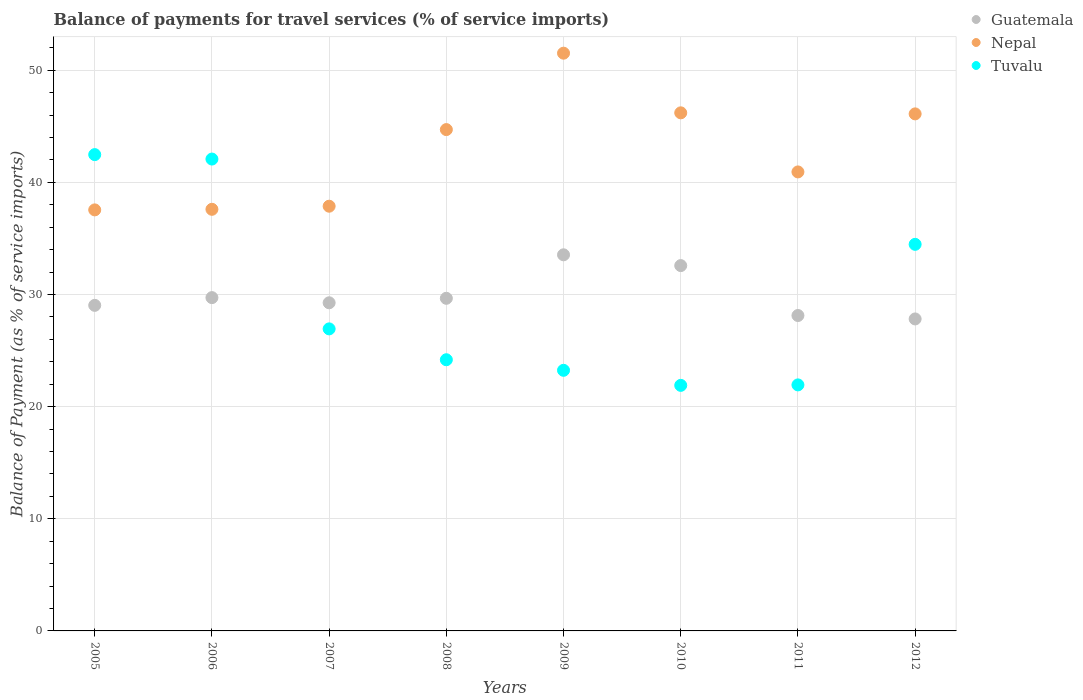How many different coloured dotlines are there?
Make the answer very short. 3. What is the balance of payments for travel services in Guatemala in 2005?
Offer a terse response. 29.03. Across all years, what is the maximum balance of payments for travel services in Tuvalu?
Offer a very short reply. 42.47. Across all years, what is the minimum balance of payments for travel services in Tuvalu?
Provide a short and direct response. 21.89. In which year was the balance of payments for travel services in Tuvalu maximum?
Provide a succinct answer. 2005. What is the total balance of payments for travel services in Tuvalu in the graph?
Ensure brevity in your answer.  237.19. What is the difference between the balance of payments for travel services in Guatemala in 2009 and that in 2010?
Provide a short and direct response. 0.96. What is the difference between the balance of payments for travel services in Tuvalu in 2007 and the balance of payments for travel services in Nepal in 2009?
Your response must be concise. -24.58. What is the average balance of payments for travel services in Nepal per year?
Provide a succinct answer. 42.8. In the year 2011, what is the difference between the balance of payments for travel services in Guatemala and balance of payments for travel services in Nepal?
Offer a terse response. -12.8. In how many years, is the balance of payments for travel services in Nepal greater than 18 %?
Your answer should be very brief. 8. What is the ratio of the balance of payments for travel services in Guatemala in 2005 to that in 2007?
Provide a short and direct response. 0.99. What is the difference between the highest and the second highest balance of payments for travel services in Guatemala?
Provide a succinct answer. 0.96. What is the difference between the highest and the lowest balance of payments for travel services in Guatemala?
Offer a terse response. 5.72. Is the balance of payments for travel services in Nepal strictly greater than the balance of payments for travel services in Guatemala over the years?
Give a very brief answer. Yes. Is the balance of payments for travel services in Guatemala strictly less than the balance of payments for travel services in Nepal over the years?
Your response must be concise. Yes. How many dotlines are there?
Your answer should be compact. 3. How many years are there in the graph?
Offer a terse response. 8. What is the difference between two consecutive major ticks on the Y-axis?
Provide a short and direct response. 10. Are the values on the major ticks of Y-axis written in scientific E-notation?
Provide a succinct answer. No. Does the graph contain any zero values?
Give a very brief answer. No. What is the title of the graph?
Offer a terse response. Balance of payments for travel services (% of service imports). What is the label or title of the Y-axis?
Offer a very short reply. Balance of Payment (as % of service imports). What is the Balance of Payment (as % of service imports) of Guatemala in 2005?
Ensure brevity in your answer.  29.03. What is the Balance of Payment (as % of service imports) of Nepal in 2005?
Offer a very short reply. 37.54. What is the Balance of Payment (as % of service imports) of Tuvalu in 2005?
Provide a succinct answer. 42.47. What is the Balance of Payment (as % of service imports) in Guatemala in 2006?
Keep it short and to the point. 29.72. What is the Balance of Payment (as % of service imports) of Nepal in 2006?
Give a very brief answer. 37.59. What is the Balance of Payment (as % of service imports) of Tuvalu in 2006?
Provide a short and direct response. 42.07. What is the Balance of Payment (as % of service imports) of Guatemala in 2007?
Your answer should be very brief. 29.26. What is the Balance of Payment (as % of service imports) of Nepal in 2007?
Make the answer very short. 37.87. What is the Balance of Payment (as % of service imports) of Tuvalu in 2007?
Offer a very short reply. 26.93. What is the Balance of Payment (as % of service imports) of Guatemala in 2008?
Provide a short and direct response. 29.66. What is the Balance of Payment (as % of service imports) of Nepal in 2008?
Your response must be concise. 44.7. What is the Balance of Payment (as % of service imports) in Tuvalu in 2008?
Keep it short and to the point. 24.18. What is the Balance of Payment (as % of service imports) of Guatemala in 2009?
Your response must be concise. 33.54. What is the Balance of Payment (as % of service imports) in Nepal in 2009?
Offer a very short reply. 51.51. What is the Balance of Payment (as % of service imports) of Tuvalu in 2009?
Offer a very short reply. 23.24. What is the Balance of Payment (as % of service imports) of Guatemala in 2010?
Offer a very short reply. 32.57. What is the Balance of Payment (as % of service imports) in Nepal in 2010?
Make the answer very short. 46.19. What is the Balance of Payment (as % of service imports) in Tuvalu in 2010?
Make the answer very short. 21.89. What is the Balance of Payment (as % of service imports) of Guatemala in 2011?
Make the answer very short. 28.12. What is the Balance of Payment (as % of service imports) of Nepal in 2011?
Your response must be concise. 40.93. What is the Balance of Payment (as % of service imports) in Tuvalu in 2011?
Give a very brief answer. 21.94. What is the Balance of Payment (as % of service imports) in Guatemala in 2012?
Keep it short and to the point. 27.82. What is the Balance of Payment (as % of service imports) of Nepal in 2012?
Make the answer very short. 46.1. What is the Balance of Payment (as % of service imports) in Tuvalu in 2012?
Provide a succinct answer. 34.47. Across all years, what is the maximum Balance of Payment (as % of service imports) of Guatemala?
Provide a short and direct response. 33.54. Across all years, what is the maximum Balance of Payment (as % of service imports) of Nepal?
Offer a very short reply. 51.51. Across all years, what is the maximum Balance of Payment (as % of service imports) in Tuvalu?
Give a very brief answer. 42.47. Across all years, what is the minimum Balance of Payment (as % of service imports) of Guatemala?
Give a very brief answer. 27.82. Across all years, what is the minimum Balance of Payment (as % of service imports) of Nepal?
Ensure brevity in your answer.  37.54. Across all years, what is the minimum Balance of Payment (as % of service imports) of Tuvalu?
Offer a very short reply. 21.89. What is the total Balance of Payment (as % of service imports) of Guatemala in the graph?
Provide a short and direct response. 239.71. What is the total Balance of Payment (as % of service imports) in Nepal in the graph?
Your answer should be very brief. 342.43. What is the total Balance of Payment (as % of service imports) of Tuvalu in the graph?
Offer a terse response. 237.19. What is the difference between the Balance of Payment (as % of service imports) in Guatemala in 2005 and that in 2006?
Your response must be concise. -0.69. What is the difference between the Balance of Payment (as % of service imports) of Nepal in 2005 and that in 2006?
Give a very brief answer. -0.05. What is the difference between the Balance of Payment (as % of service imports) of Tuvalu in 2005 and that in 2006?
Your response must be concise. 0.4. What is the difference between the Balance of Payment (as % of service imports) in Guatemala in 2005 and that in 2007?
Ensure brevity in your answer.  -0.23. What is the difference between the Balance of Payment (as % of service imports) of Nepal in 2005 and that in 2007?
Provide a short and direct response. -0.33. What is the difference between the Balance of Payment (as % of service imports) of Tuvalu in 2005 and that in 2007?
Offer a terse response. 15.54. What is the difference between the Balance of Payment (as % of service imports) in Guatemala in 2005 and that in 2008?
Offer a very short reply. -0.63. What is the difference between the Balance of Payment (as % of service imports) of Nepal in 2005 and that in 2008?
Keep it short and to the point. -7.16. What is the difference between the Balance of Payment (as % of service imports) of Tuvalu in 2005 and that in 2008?
Your response must be concise. 18.29. What is the difference between the Balance of Payment (as % of service imports) of Guatemala in 2005 and that in 2009?
Ensure brevity in your answer.  -4.51. What is the difference between the Balance of Payment (as % of service imports) in Nepal in 2005 and that in 2009?
Your response must be concise. -13.97. What is the difference between the Balance of Payment (as % of service imports) in Tuvalu in 2005 and that in 2009?
Offer a terse response. 19.23. What is the difference between the Balance of Payment (as % of service imports) in Guatemala in 2005 and that in 2010?
Provide a short and direct response. -3.54. What is the difference between the Balance of Payment (as % of service imports) of Nepal in 2005 and that in 2010?
Keep it short and to the point. -8.65. What is the difference between the Balance of Payment (as % of service imports) in Tuvalu in 2005 and that in 2010?
Your response must be concise. 20.57. What is the difference between the Balance of Payment (as % of service imports) in Guatemala in 2005 and that in 2011?
Offer a terse response. 0.91. What is the difference between the Balance of Payment (as % of service imports) of Nepal in 2005 and that in 2011?
Offer a very short reply. -3.39. What is the difference between the Balance of Payment (as % of service imports) in Tuvalu in 2005 and that in 2011?
Ensure brevity in your answer.  20.53. What is the difference between the Balance of Payment (as % of service imports) in Guatemala in 2005 and that in 2012?
Your response must be concise. 1.21. What is the difference between the Balance of Payment (as % of service imports) of Nepal in 2005 and that in 2012?
Provide a succinct answer. -8.56. What is the difference between the Balance of Payment (as % of service imports) of Tuvalu in 2005 and that in 2012?
Ensure brevity in your answer.  8. What is the difference between the Balance of Payment (as % of service imports) of Guatemala in 2006 and that in 2007?
Give a very brief answer. 0.46. What is the difference between the Balance of Payment (as % of service imports) in Nepal in 2006 and that in 2007?
Offer a very short reply. -0.28. What is the difference between the Balance of Payment (as % of service imports) in Tuvalu in 2006 and that in 2007?
Your answer should be very brief. 15.14. What is the difference between the Balance of Payment (as % of service imports) in Guatemala in 2006 and that in 2008?
Your answer should be very brief. 0.06. What is the difference between the Balance of Payment (as % of service imports) of Nepal in 2006 and that in 2008?
Your response must be concise. -7.11. What is the difference between the Balance of Payment (as % of service imports) of Tuvalu in 2006 and that in 2008?
Your answer should be compact. 17.89. What is the difference between the Balance of Payment (as % of service imports) in Guatemala in 2006 and that in 2009?
Offer a terse response. -3.82. What is the difference between the Balance of Payment (as % of service imports) in Nepal in 2006 and that in 2009?
Offer a very short reply. -13.92. What is the difference between the Balance of Payment (as % of service imports) in Tuvalu in 2006 and that in 2009?
Give a very brief answer. 18.84. What is the difference between the Balance of Payment (as % of service imports) in Guatemala in 2006 and that in 2010?
Your response must be concise. -2.86. What is the difference between the Balance of Payment (as % of service imports) of Nepal in 2006 and that in 2010?
Give a very brief answer. -8.6. What is the difference between the Balance of Payment (as % of service imports) in Tuvalu in 2006 and that in 2010?
Your answer should be very brief. 20.18. What is the difference between the Balance of Payment (as % of service imports) in Guatemala in 2006 and that in 2011?
Your response must be concise. 1.59. What is the difference between the Balance of Payment (as % of service imports) in Nepal in 2006 and that in 2011?
Offer a very short reply. -3.33. What is the difference between the Balance of Payment (as % of service imports) of Tuvalu in 2006 and that in 2011?
Provide a succinct answer. 20.14. What is the difference between the Balance of Payment (as % of service imports) of Guatemala in 2006 and that in 2012?
Keep it short and to the point. 1.9. What is the difference between the Balance of Payment (as % of service imports) in Nepal in 2006 and that in 2012?
Your answer should be very brief. -8.51. What is the difference between the Balance of Payment (as % of service imports) in Tuvalu in 2006 and that in 2012?
Provide a short and direct response. 7.6. What is the difference between the Balance of Payment (as % of service imports) in Guatemala in 2007 and that in 2008?
Provide a succinct answer. -0.4. What is the difference between the Balance of Payment (as % of service imports) of Nepal in 2007 and that in 2008?
Make the answer very short. -6.83. What is the difference between the Balance of Payment (as % of service imports) of Tuvalu in 2007 and that in 2008?
Keep it short and to the point. 2.75. What is the difference between the Balance of Payment (as % of service imports) in Guatemala in 2007 and that in 2009?
Make the answer very short. -4.28. What is the difference between the Balance of Payment (as % of service imports) in Nepal in 2007 and that in 2009?
Make the answer very short. -13.64. What is the difference between the Balance of Payment (as % of service imports) in Tuvalu in 2007 and that in 2009?
Make the answer very short. 3.69. What is the difference between the Balance of Payment (as % of service imports) of Guatemala in 2007 and that in 2010?
Your answer should be compact. -3.32. What is the difference between the Balance of Payment (as % of service imports) of Nepal in 2007 and that in 2010?
Provide a short and direct response. -8.33. What is the difference between the Balance of Payment (as % of service imports) in Tuvalu in 2007 and that in 2010?
Keep it short and to the point. 5.04. What is the difference between the Balance of Payment (as % of service imports) in Guatemala in 2007 and that in 2011?
Provide a succinct answer. 1.13. What is the difference between the Balance of Payment (as % of service imports) in Nepal in 2007 and that in 2011?
Give a very brief answer. -3.06. What is the difference between the Balance of Payment (as % of service imports) of Tuvalu in 2007 and that in 2011?
Offer a terse response. 4.99. What is the difference between the Balance of Payment (as % of service imports) of Guatemala in 2007 and that in 2012?
Ensure brevity in your answer.  1.44. What is the difference between the Balance of Payment (as % of service imports) in Nepal in 2007 and that in 2012?
Your response must be concise. -8.23. What is the difference between the Balance of Payment (as % of service imports) in Tuvalu in 2007 and that in 2012?
Give a very brief answer. -7.54. What is the difference between the Balance of Payment (as % of service imports) of Guatemala in 2008 and that in 2009?
Give a very brief answer. -3.88. What is the difference between the Balance of Payment (as % of service imports) in Nepal in 2008 and that in 2009?
Your answer should be compact. -6.81. What is the difference between the Balance of Payment (as % of service imports) in Tuvalu in 2008 and that in 2009?
Give a very brief answer. 0.94. What is the difference between the Balance of Payment (as % of service imports) in Guatemala in 2008 and that in 2010?
Offer a very short reply. -2.92. What is the difference between the Balance of Payment (as % of service imports) in Nepal in 2008 and that in 2010?
Ensure brevity in your answer.  -1.49. What is the difference between the Balance of Payment (as % of service imports) of Tuvalu in 2008 and that in 2010?
Keep it short and to the point. 2.28. What is the difference between the Balance of Payment (as % of service imports) of Guatemala in 2008 and that in 2011?
Provide a succinct answer. 1.53. What is the difference between the Balance of Payment (as % of service imports) in Nepal in 2008 and that in 2011?
Offer a very short reply. 3.77. What is the difference between the Balance of Payment (as % of service imports) of Tuvalu in 2008 and that in 2011?
Offer a very short reply. 2.24. What is the difference between the Balance of Payment (as % of service imports) of Guatemala in 2008 and that in 2012?
Your response must be concise. 1.84. What is the difference between the Balance of Payment (as % of service imports) of Nepal in 2008 and that in 2012?
Your answer should be compact. -1.4. What is the difference between the Balance of Payment (as % of service imports) in Tuvalu in 2008 and that in 2012?
Offer a terse response. -10.29. What is the difference between the Balance of Payment (as % of service imports) in Guatemala in 2009 and that in 2010?
Make the answer very short. 0.96. What is the difference between the Balance of Payment (as % of service imports) in Nepal in 2009 and that in 2010?
Offer a very short reply. 5.32. What is the difference between the Balance of Payment (as % of service imports) in Tuvalu in 2009 and that in 2010?
Your answer should be very brief. 1.34. What is the difference between the Balance of Payment (as % of service imports) of Guatemala in 2009 and that in 2011?
Provide a succinct answer. 5.41. What is the difference between the Balance of Payment (as % of service imports) in Nepal in 2009 and that in 2011?
Provide a succinct answer. 10.59. What is the difference between the Balance of Payment (as % of service imports) in Tuvalu in 2009 and that in 2011?
Your response must be concise. 1.3. What is the difference between the Balance of Payment (as % of service imports) in Guatemala in 2009 and that in 2012?
Ensure brevity in your answer.  5.72. What is the difference between the Balance of Payment (as % of service imports) in Nepal in 2009 and that in 2012?
Make the answer very short. 5.41. What is the difference between the Balance of Payment (as % of service imports) in Tuvalu in 2009 and that in 2012?
Your response must be concise. -11.23. What is the difference between the Balance of Payment (as % of service imports) of Guatemala in 2010 and that in 2011?
Make the answer very short. 4.45. What is the difference between the Balance of Payment (as % of service imports) in Nepal in 2010 and that in 2011?
Offer a very short reply. 5.27. What is the difference between the Balance of Payment (as % of service imports) in Tuvalu in 2010 and that in 2011?
Give a very brief answer. -0.04. What is the difference between the Balance of Payment (as % of service imports) of Guatemala in 2010 and that in 2012?
Offer a terse response. 4.76. What is the difference between the Balance of Payment (as % of service imports) in Nepal in 2010 and that in 2012?
Give a very brief answer. 0.09. What is the difference between the Balance of Payment (as % of service imports) of Tuvalu in 2010 and that in 2012?
Keep it short and to the point. -12.57. What is the difference between the Balance of Payment (as % of service imports) of Guatemala in 2011 and that in 2012?
Your answer should be very brief. 0.31. What is the difference between the Balance of Payment (as % of service imports) in Nepal in 2011 and that in 2012?
Provide a succinct answer. -5.17. What is the difference between the Balance of Payment (as % of service imports) of Tuvalu in 2011 and that in 2012?
Your response must be concise. -12.53. What is the difference between the Balance of Payment (as % of service imports) of Guatemala in 2005 and the Balance of Payment (as % of service imports) of Nepal in 2006?
Make the answer very short. -8.56. What is the difference between the Balance of Payment (as % of service imports) of Guatemala in 2005 and the Balance of Payment (as % of service imports) of Tuvalu in 2006?
Make the answer very short. -13.04. What is the difference between the Balance of Payment (as % of service imports) of Nepal in 2005 and the Balance of Payment (as % of service imports) of Tuvalu in 2006?
Your answer should be very brief. -4.53. What is the difference between the Balance of Payment (as % of service imports) in Guatemala in 2005 and the Balance of Payment (as % of service imports) in Nepal in 2007?
Keep it short and to the point. -8.84. What is the difference between the Balance of Payment (as % of service imports) in Guatemala in 2005 and the Balance of Payment (as % of service imports) in Tuvalu in 2007?
Give a very brief answer. 2.1. What is the difference between the Balance of Payment (as % of service imports) of Nepal in 2005 and the Balance of Payment (as % of service imports) of Tuvalu in 2007?
Provide a short and direct response. 10.61. What is the difference between the Balance of Payment (as % of service imports) in Guatemala in 2005 and the Balance of Payment (as % of service imports) in Nepal in 2008?
Your answer should be compact. -15.67. What is the difference between the Balance of Payment (as % of service imports) of Guatemala in 2005 and the Balance of Payment (as % of service imports) of Tuvalu in 2008?
Your answer should be compact. 4.85. What is the difference between the Balance of Payment (as % of service imports) of Nepal in 2005 and the Balance of Payment (as % of service imports) of Tuvalu in 2008?
Ensure brevity in your answer.  13.36. What is the difference between the Balance of Payment (as % of service imports) in Guatemala in 2005 and the Balance of Payment (as % of service imports) in Nepal in 2009?
Your response must be concise. -22.48. What is the difference between the Balance of Payment (as % of service imports) in Guatemala in 2005 and the Balance of Payment (as % of service imports) in Tuvalu in 2009?
Provide a short and direct response. 5.79. What is the difference between the Balance of Payment (as % of service imports) of Nepal in 2005 and the Balance of Payment (as % of service imports) of Tuvalu in 2009?
Offer a terse response. 14.3. What is the difference between the Balance of Payment (as % of service imports) of Guatemala in 2005 and the Balance of Payment (as % of service imports) of Nepal in 2010?
Your response must be concise. -17.16. What is the difference between the Balance of Payment (as % of service imports) in Guatemala in 2005 and the Balance of Payment (as % of service imports) in Tuvalu in 2010?
Keep it short and to the point. 7.13. What is the difference between the Balance of Payment (as % of service imports) of Nepal in 2005 and the Balance of Payment (as % of service imports) of Tuvalu in 2010?
Your answer should be very brief. 15.65. What is the difference between the Balance of Payment (as % of service imports) in Guatemala in 2005 and the Balance of Payment (as % of service imports) in Nepal in 2011?
Offer a terse response. -11.9. What is the difference between the Balance of Payment (as % of service imports) of Guatemala in 2005 and the Balance of Payment (as % of service imports) of Tuvalu in 2011?
Offer a very short reply. 7.09. What is the difference between the Balance of Payment (as % of service imports) of Nepal in 2005 and the Balance of Payment (as % of service imports) of Tuvalu in 2011?
Offer a very short reply. 15.6. What is the difference between the Balance of Payment (as % of service imports) in Guatemala in 2005 and the Balance of Payment (as % of service imports) in Nepal in 2012?
Provide a succinct answer. -17.07. What is the difference between the Balance of Payment (as % of service imports) of Guatemala in 2005 and the Balance of Payment (as % of service imports) of Tuvalu in 2012?
Provide a succinct answer. -5.44. What is the difference between the Balance of Payment (as % of service imports) of Nepal in 2005 and the Balance of Payment (as % of service imports) of Tuvalu in 2012?
Offer a terse response. 3.07. What is the difference between the Balance of Payment (as % of service imports) in Guatemala in 2006 and the Balance of Payment (as % of service imports) in Nepal in 2007?
Your answer should be compact. -8.15. What is the difference between the Balance of Payment (as % of service imports) of Guatemala in 2006 and the Balance of Payment (as % of service imports) of Tuvalu in 2007?
Ensure brevity in your answer.  2.79. What is the difference between the Balance of Payment (as % of service imports) in Nepal in 2006 and the Balance of Payment (as % of service imports) in Tuvalu in 2007?
Ensure brevity in your answer.  10.66. What is the difference between the Balance of Payment (as % of service imports) in Guatemala in 2006 and the Balance of Payment (as % of service imports) in Nepal in 2008?
Keep it short and to the point. -14.98. What is the difference between the Balance of Payment (as % of service imports) of Guatemala in 2006 and the Balance of Payment (as % of service imports) of Tuvalu in 2008?
Offer a very short reply. 5.54. What is the difference between the Balance of Payment (as % of service imports) in Nepal in 2006 and the Balance of Payment (as % of service imports) in Tuvalu in 2008?
Offer a very short reply. 13.41. What is the difference between the Balance of Payment (as % of service imports) of Guatemala in 2006 and the Balance of Payment (as % of service imports) of Nepal in 2009?
Keep it short and to the point. -21.79. What is the difference between the Balance of Payment (as % of service imports) of Guatemala in 2006 and the Balance of Payment (as % of service imports) of Tuvalu in 2009?
Your answer should be compact. 6.48. What is the difference between the Balance of Payment (as % of service imports) in Nepal in 2006 and the Balance of Payment (as % of service imports) in Tuvalu in 2009?
Keep it short and to the point. 14.36. What is the difference between the Balance of Payment (as % of service imports) in Guatemala in 2006 and the Balance of Payment (as % of service imports) in Nepal in 2010?
Provide a short and direct response. -16.48. What is the difference between the Balance of Payment (as % of service imports) in Guatemala in 2006 and the Balance of Payment (as % of service imports) in Tuvalu in 2010?
Ensure brevity in your answer.  7.82. What is the difference between the Balance of Payment (as % of service imports) in Nepal in 2006 and the Balance of Payment (as % of service imports) in Tuvalu in 2010?
Your answer should be very brief. 15.7. What is the difference between the Balance of Payment (as % of service imports) in Guatemala in 2006 and the Balance of Payment (as % of service imports) in Nepal in 2011?
Ensure brevity in your answer.  -11.21. What is the difference between the Balance of Payment (as % of service imports) of Guatemala in 2006 and the Balance of Payment (as % of service imports) of Tuvalu in 2011?
Keep it short and to the point. 7.78. What is the difference between the Balance of Payment (as % of service imports) of Nepal in 2006 and the Balance of Payment (as % of service imports) of Tuvalu in 2011?
Give a very brief answer. 15.66. What is the difference between the Balance of Payment (as % of service imports) of Guatemala in 2006 and the Balance of Payment (as % of service imports) of Nepal in 2012?
Ensure brevity in your answer.  -16.38. What is the difference between the Balance of Payment (as % of service imports) in Guatemala in 2006 and the Balance of Payment (as % of service imports) in Tuvalu in 2012?
Keep it short and to the point. -4.75. What is the difference between the Balance of Payment (as % of service imports) of Nepal in 2006 and the Balance of Payment (as % of service imports) of Tuvalu in 2012?
Offer a very short reply. 3.12. What is the difference between the Balance of Payment (as % of service imports) of Guatemala in 2007 and the Balance of Payment (as % of service imports) of Nepal in 2008?
Your answer should be compact. -15.44. What is the difference between the Balance of Payment (as % of service imports) of Guatemala in 2007 and the Balance of Payment (as % of service imports) of Tuvalu in 2008?
Ensure brevity in your answer.  5.08. What is the difference between the Balance of Payment (as % of service imports) of Nepal in 2007 and the Balance of Payment (as % of service imports) of Tuvalu in 2008?
Ensure brevity in your answer.  13.69. What is the difference between the Balance of Payment (as % of service imports) of Guatemala in 2007 and the Balance of Payment (as % of service imports) of Nepal in 2009?
Make the answer very short. -22.25. What is the difference between the Balance of Payment (as % of service imports) of Guatemala in 2007 and the Balance of Payment (as % of service imports) of Tuvalu in 2009?
Offer a terse response. 6.02. What is the difference between the Balance of Payment (as % of service imports) in Nepal in 2007 and the Balance of Payment (as % of service imports) in Tuvalu in 2009?
Make the answer very short. 14.63. What is the difference between the Balance of Payment (as % of service imports) in Guatemala in 2007 and the Balance of Payment (as % of service imports) in Nepal in 2010?
Provide a short and direct response. -16.94. What is the difference between the Balance of Payment (as % of service imports) in Guatemala in 2007 and the Balance of Payment (as % of service imports) in Tuvalu in 2010?
Your response must be concise. 7.36. What is the difference between the Balance of Payment (as % of service imports) of Nepal in 2007 and the Balance of Payment (as % of service imports) of Tuvalu in 2010?
Your response must be concise. 15.97. What is the difference between the Balance of Payment (as % of service imports) of Guatemala in 2007 and the Balance of Payment (as % of service imports) of Nepal in 2011?
Give a very brief answer. -11.67. What is the difference between the Balance of Payment (as % of service imports) in Guatemala in 2007 and the Balance of Payment (as % of service imports) in Tuvalu in 2011?
Your response must be concise. 7.32. What is the difference between the Balance of Payment (as % of service imports) of Nepal in 2007 and the Balance of Payment (as % of service imports) of Tuvalu in 2011?
Your answer should be very brief. 15.93. What is the difference between the Balance of Payment (as % of service imports) of Guatemala in 2007 and the Balance of Payment (as % of service imports) of Nepal in 2012?
Ensure brevity in your answer.  -16.84. What is the difference between the Balance of Payment (as % of service imports) of Guatemala in 2007 and the Balance of Payment (as % of service imports) of Tuvalu in 2012?
Keep it short and to the point. -5.21. What is the difference between the Balance of Payment (as % of service imports) in Nepal in 2007 and the Balance of Payment (as % of service imports) in Tuvalu in 2012?
Your answer should be very brief. 3.4. What is the difference between the Balance of Payment (as % of service imports) in Guatemala in 2008 and the Balance of Payment (as % of service imports) in Nepal in 2009?
Offer a very short reply. -21.86. What is the difference between the Balance of Payment (as % of service imports) in Guatemala in 2008 and the Balance of Payment (as % of service imports) in Tuvalu in 2009?
Make the answer very short. 6.42. What is the difference between the Balance of Payment (as % of service imports) of Nepal in 2008 and the Balance of Payment (as % of service imports) of Tuvalu in 2009?
Your answer should be very brief. 21.46. What is the difference between the Balance of Payment (as % of service imports) in Guatemala in 2008 and the Balance of Payment (as % of service imports) in Nepal in 2010?
Offer a terse response. -16.54. What is the difference between the Balance of Payment (as % of service imports) in Guatemala in 2008 and the Balance of Payment (as % of service imports) in Tuvalu in 2010?
Provide a short and direct response. 7.76. What is the difference between the Balance of Payment (as % of service imports) of Nepal in 2008 and the Balance of Payment (as % of service imports) of Tuvalu in 2010?
Ensure brevity in your answer.  22.81. What is the difference between the Balance of Payment (as % of service imports) in Guatemala in 2008 and the Balance of Payment (as % of service imports) in Nepal in 2011?
Your answer should be very brief. -11.27. What is the difference between the Balance of Payment (as % of service imports) in Guatemala in 2008 and the Balance of Payment (as % of service imports) in Tuvalu in 2011?
Provide a short and direct response. 7.72. What is the difference between the Balance of Payment (as % of service imports) in Nepal in 2008 and the Balance of Payment (as % of service imports) in Tuvalu in 2011?
Your answer should be compact. 22.76. What is the difference between the Balance of Payment (as % of service imports) of Guatemala in 2008 and the Balance of Payment (as % of service imports) of Nepal in 2012?
Make the answer very short. -16.44. What is the difference between the Balance of Payment (as % of service imports) in Guatemala in 2008 and the Balance of Payment (as % of service imports) in Tuvalu in 2012?
Ensure brevity in your answer.  -4.81. What is the difference between the Balance of Payment (as % of service imports) of Nepal in 2008 and the Balance of Payment (as % of service imports) of Tuvalu in 2012?
Offer a very short reply. 10.23. What is the difference between the Balance of Payment (as % of service imports) of Guatemala in 2009 and the Balance of Payment (as % of service imports) of Nepal in 2010?
Make the answer very short. -12.66. What is the difference between the Balance of Payment (as % of service imports) in Guatemala in 2009 and the Balance of Payment (as % of service imports) in Tuvalu in 2010?
Your answer should be compact. 11.64. What is the difference between the Balance of Payment (as % of service imports) in Nepal in 2009 and the Balance of Payment (as % of service imports) in Tuvalu in 2010?
Your answer should be compact. 29.62. What is the difference between the Balance of Payment (as % of service imports) of Guatemala in 2009 and the Balance of Payment (as % of service imports) of Nepal in 2011?
Make the answer very short. -7.39. What is the difference between the Balance of Payment (as % of service imports) in Guatemala in 2009 and the Balance of Payment (as % of service imports) in Tuvalu in 2011?
Keep it short and to the point. 11.6. What is the difference between the Balance of Payment (as % of service imports) of Nepal in 2009 and the Balance of Payment (as % of service imports) of Tuvalu in 2011?
Give a very brief answer. 29.58. What is the difference between the Balance of Payment (as % of service imports) in Guatemala in 2009 and the Balance of Payment (as % of service imports) in Nepal in 2012?
Your answer should be compact. -12.56. What is the difference between the Balance of Payment (as % of service imports) of Guatemala in 2009 and the Balance of Payment (as % of service imports) of Tuvalu in 2012?
Make the answer very short. -0.93. What is the difference between the Balance of Payment (as % of service imports) in Nepal in 2009 and the Balance of Payment (as % of service imports) in Tuvalu in 2012?
Provide a short and direct response. 17.04. What is the difference between the Balance of Payment (as % of service imports) of Guatemala in 2010 and the Balance of Payment (as % of service imports) of Nepal in 2011?
Give a very brief answer. -8.35. What is the difference between the Balance of Payment (as % of service imports) in Guatemala in 2010 and the Balance of Payment (as % of service imports) in Tuvalu in 2011?
Provide a short and direct response. 10.64. What is the difference between the Balance of Payment (as % of service imports) of Nepal in 2010 and the Balance of Payment (as % of service imports) of Tuvalu in 2011?
Provide a short and direct response. 24.26. What is the difference between the Balance of Payment (as % of service imports) of Guatemala in 2010 and the Balance of Payment (as % of service imports) of Nepal in 2012?
Your response must be concise. -13.53. What is the difference between the Balance of Payment (as % of service imports) in Guatemala in 2010 and the Balance of Payment (as % of service imports) in Tuvalu in 2012?
Ensure brevity in your answer.  -1.9. What is the difference between the Balance of Payment (as % of service imports) of Nepal in 2010 and the Balance of Payment (as % of service imports) of Tuvalu in 2012?
Offer a very short reply. 11.73. What is the difference between the Balance of Payment (as % of service imports) in Guatemala in 2011 and the Balance of Payment (as % of service imports) in Nepal in 2012?
Your answer should be compact. -17.98. What is the difference between the Balance of Payment (as % of service imports) of Guatemala in 2011 and the Balance of Payment (as % of service imports) of Tuvalu in 2012?
Your answer should be compact. -6.35. What is the difference between the Balance of Payment (as % of service imports) of Nepal in 2011 and the Balance of Payment (as % of service imports) of Tuvalu in 2012?
Provide a succinct answer. 6.46. What is the average Balance of Payment (as % of service imports) in Guatemala per year?
Your answer should be very brief. 29.96. What is the average Balance of Payment (as % of service imports) of Nepal per year?
Provide a short and direct response. 42.8. What is the average Balance of Payment (as % of service imports) of Tuvalu per year?
Offer a terse response. 29.65. In the year 2005, what is the difference between the Balance of Payment (as % of service imports) in Guatemala and Balance of Payment (as % of service imports) in Nepal?
Your response must be concise. -8.51. In the year 2005, what is the difference between the Balance of Payment (as % of service imports) of Guatemala and Balance of Payment (as % of service imports) of Tuvalu?
Ensure brevity in your answer.  -13.44. In the year 2005, what is the difference between the Balance of Payment (as % of service imports) of Nepal and Balance of Payment (as % of service imports) of Tuvalu?
Offer a terse response. -4.93. In the year 2006, what is the difference between the Balance of Payment (as % of service imports) of Guatemala and Balance of Payment (as % of service imports) of Nepal?
Provide a short and direct response. -7.87. In the year 2006, what is the difference between the Balance of Payment (as % of service imports) in Guatemala and Balance of Payment (as % of service imports) in Tuvalu?
Provide a succinct answer. -12.35. In the year 2006, what is the difference between the Balance of Payment (as % of service imports) of Nepal and Balance of Payment (as % of service imports) of Tuvalu?
Offer a terse response. -4.48. In the year 2007, what is the difference between the Balance of Payment (as % of service imports) in Guatemala and Balance of Payment (as % of service imports) in Nepal?
Make the answer very short. -8.61. In the year 2007, what is the difference between the Balance of Payment (as % of service imports) of Guatemala and Balance of Payment (as % of service imports) of Tuvalu?
Keep it short and to the point. 2.33. In the year 2007, what is the difference between the Balance of Payment (as % of service imports) of Nepal and Balance of Payment (as % of service imports) of Tuvalu?
Provide a short and direct response. 10.94. In the year 2008, what is the difference between the Balance of Payment (as % of service imports) in Guatemala and Balance of Payment (as % of service imports) in Nepal?
Offer a very short reply. -15.04. In the year 2008, what is the difference between the Balance of Payment (as % of service imports) of Guatemala and Balance of Payment (as % of service imports) of Tuvalu?
Your answer should be compact. 5.48. In the year 2008, what is the difference between the Balance of Payment (as % of service imports) in Nepal and Balance of Payment (as % of service imports) in Tuvalu?
Keep it short and to the point. 20.52. In the year 2009, what is the difference between the Balance of Payment (as % of service imports) in Guatemala and Balance of Payment (as % of service imports) in Nepal?
Your answer should be very brief. -17.98. In the year 2009, what is the difference between the Balance of Payment (as % of service imports) of Guatemala and Balance of Payment (as % of service imports) of Tuvalu?
Provide a succinct answer. 10.3. In the year 2009, what is the difference between the Balance of Payment (as % of service imports) in Nepal and Balance of Payment (as % of service imports) in Tuvalu?
Offer a terse response. 28.28. In the year 2010, what is the difference between the Balance of Payment (as % of service imports) in Guatemala and Balance of Payment (as % of service imports) in Nepal?
Your response must be concise. -13.62. In the year 2010, what is the difference between the Balance of Payment (as % of service imports) in Guatemala and Balance of Payment (as % of service imports) in Tuvalu?
Your answer should be compact. 10.68. In the year 2010, what is the difference between the Balance of Payment (as % of service imports) in Nepal and Balance of Payment (as % of service imports) in Tuvalu?
Your answer should be very brief. 24.3. In the year 2011, what is the difference between the Balance of Payment (as % of service imports) in Guatemala and Balance of Payment (as % of service imports) in Nepal?
Your answer should be very brief. -12.8. In the year 2011, what is the difference between the Balance of Payment (as % of service imports) of Guatemala and Balance of Payment (as % of service imports) of Tuvalu?
Offer a very short reply. 6.19. In the year 2011, what is the difference between the Balance of Payment (as % of service imports) of Nepal and Balance of Payment (as % of service imports) of Tuvalu?
Your answer should be compact. 18.99. In the year 2012, what is the difference between the Balance of Payment (as % of service imports) of Guatemala and Balance of Payment (as % of service imports) of Nepal?
Ensure brevity in your answer.  -18.28. In the year 2012, what is the difference between the Balance of Payment (as % of service imports) of Guatemala and Balance of Payment (as % of service imports) of Tuvalu?
Provide a short and direct response. -6.65. In the year 2012, what is the difference between the Balance of Payment (as % of service imports) of Nepal and Balance of Payment (as % of service imports) of Tuvalu?
Your answer should be very brief. 11.63. What is the ratio of the Balance of Payment (as % of service imports) in Guatemala in 2005 to that in 2006?
Your answer should be compact. 0.98. What is the ratio of the Balance of Payment (as % of service imports) of Tuvalu in 2005 to that in 2006?
Ensure brevity in your answer.  1.01. What is the ratio of the Balance of Payment (as % of service imports) of Tuvalu in 2005 to that in 2007?
Your response must be concise. 1.58. What is the ratio of the Balance of Payment (as % of service imports) of Guatemala in 2005 to that in 2008?
Give a very brief answer. 0.98. What is the ratio of the Balance of Payment (as % of service imports) of Nepal in 2005 to that in 2008?
Offer a terse response. 0.84. What is the ratio of the Balance of Payment (as % of service imports) of Tuvalu in 2005 to that in 2008?
Offer a very short reply. 1.76. What is the ratio of the Balance of Payment (as % of service imports) in Guatemala in 2005 to that in 2009?
Provide a short and direct response. 0.87. What is the ratio of the Balance of Payment (as % of service imports) of Nepal in 2005 to that in 2009?
Provide a succinct answer. 0.73. What is the ratio of the Balance of Payment (as % of service imports) of Tuvalu in 2005 to that in 2009?
Your response must be concise. 1.83. What is the ratio of the Balance of Payment (as % of service imports) in Guatemala in 2005 to that in 2010?
Provide a short and direct response. 0.89. What is the ratio of the Balance of Payment (as % of service imports) in Nepal in 2005 to that in 2010?
Your response must be concise. 0.81. What is the ratio of the Balance of Payment (as % of service imports) of Tuvalu in 2005 to that in 2010?
Offer a very short reply. 1.94. What is the ratio of the Balance of Payment (as % of service imports) in Guatemala in 2005 to that in 2011?
Offer a terse response. 1.03. What is the ratio of the Balance of Payment (as % of service imports) of Nepal in 2005 to that in 2011?
Keep it short and to the point. 0.92. What is the ratio of the Balance of Payment (as % of service imports) of Tuvalu in 2005 to that in 2011?
Offer a terse response. 1.94. What is the ratio of the Balance of Payment (as % of service imports) in Guatemala in 2005 to that in 2012?
Your answer should be very brief. 1.04. What is the ratio of the Balance of Payment (as % of service imports) in Nepal in 2005 to that in 2012?
Ensure brevity in your answer.  0.81. What is the ratio of the Balance of Payment (as % of service imports) in Tuvalu in 2005 to that in 2012?
Offer a very short reply. 1.23. What is the ratio of the Balance of Payment (as % of service imports) in Guatemala in 2006 to that in 2007?
Provide a succinct answer. 1.02. What is the ratio of the Balance of Payment (as % of service imports) in Nepal in 2006 to that in 2007?
Make the answer very short. 0.99. What is the ratio of the Balance of Payment (as % of service imports) of Tuvalu in 2006 to that in 2007?
Provide a succinct answer. 1.56. What is the ratio of the Balance of Payment (as % of service imports) of Guatemala in 2006 to that in 2008?
Provide a short and direct response. 1. What is the ratio of the Balance of Payment (as % of service imports) of Nepal in 2006 to that in 2008?
Offer a terse response. 0.84. What is the ratio of the Balance of Payment (as % of service imports) in Tuvalu in 2006 to that in 2008?
Provide a succinct answer. 1.74. What is the ratio of the Balance of Payment (as % of service imports) of Guatemala in 2006 to that in 2009?
Your answer should be very brief. 0.89. What is the ratio of the Balance of Payment (as % of service imports) in Nepal in 2006 to that in 2009?
Provide a short and direct response. 0.73. What is the ratio of the Balance of Payment (as % of service imports) of Tuvalu in 2006 to that in 2009?
Your answer should be compact. 1.81. What is the ratio of the Balance of Payment (as % of service imports) of Guatemala in 2006 to that in 2010?
Provide a short and direct response. 0.91. What is the ratio of the Balance of Payment (as % of service imports) of Nepal in 2006 to that in 2010?
Keep it short and to the point. 0.81. What is the ratio of the Balance of Payment (as % of service imports) in Tuvalu in 2006 to that in 2010?
Your response must be concise. 1.92. What is the ratio of the Balance of Payment (as % of service imports) in Guatemala in 2006 to that in 2011?
Your answer should be compact. 1.06. What is the ratio of the Balance of Payment (as % of service imports) of Nepal in 2006 to that in 2011?
Ensure brevity in your answer.  0.92. What is the ratio of the Balance of Payment (as % of service imports) in Tuvalu in 2006 to that in 2011?
Give a very brief answer. 1.92. What is the ratio of the Balance of Payment (as % of service imports) of Guatemala in 2006 to that in 2012?
Ensure brevity in your answer.  1.07. What is the ratio of the Balance of Payment (as % of service imports) of Nepal in 2006 to that in 2012?
Offer a very short reply. 0.82. What is the ratio of the Balance of Payment (as % of service imports) in Tuvalu in 2006 to that in 2012?
Offer a very short reply. 1.22. What is the ratio of the Balance of Payment (as % of service imports) in Guatemala in 2007 to that in 2008?
Provide a short and direct response. 0.99. What is the ratio of the Balance of Payment (as % of service imports) in Nepal in 2007 to that in 2008?
Keep it short and to the point. 0.85. What is the ratio of the Balance of Payment (as % of service imports) in Tuvalu in 2007 to that in 2008?
Your response must be concise. 1.11. What is the ratio of the Balance of Payment (as % of service imports) of Guatemala in 2007 to that in 2009?
Keep it short and to the point. 0.87. What is the ratio of the Balance of Payment (as % of service imports) in Nepal in 2007 to that in 2009?
Offer a very short reply. 0.74. What is the ratio of the Balance of Payment (as % of service imports) in Tuvalu in 2007 to that in 2009?
Provide a short and direct response. 1.16. What is the ratio of the Balance of Payment (as % of service imports) of Guatemala in 2007 to that in 2010?
Provide a short and direct response. 0.9. What is the ratio of the Balance of Payment (as % of service imports) of Nepal in 2007 to that in 2010?
Make the answer very short. 0.82. What is the ratio of the Balance of Payment (as % of service imports) of Tuvalu in 2007 to that in 2010?
Provide a succinct answer. 1.23. What is the ratio of the Balance of Payment (as % of service imports) in Guatemala in 2007 to that in 2011?
Your answer should be very brief. 1.04. What is the ratio of the Balance of Payment (as % of service imports) in Nepal in 2007 to that in 2011?
Keep it short and to the point. 0.93. What is the ratio of the Balance of Payment (as % of service imports) of Tuvalu in 2007 to that in 2011?
Your response must be concise. 1.23. What is the ratio of the Balance of Payment (as % of service imports) in Guatemala in 2007 to that in 2012?
Provide a short and direct response. 1.05. What is the ratio of the Balance of Payment (as % of service imports) in Nepal in 2007 to that in 2012?
Offer a terse response. 0.82. What is the ratio of the Balance of Payment (as % of service imports) of Tuvalu in 2007 to that in 2012?
Provide a short and direct response. 0.78. What is the ratio of the Balance of Payment (as % of service imports) of Guatemala in 2008 to that in 2009?
Your response must be concise. 0.88. What is the ratio of the Balance of Payment (as % of service imports) of Nepal in 2008 to that in 2009?
Keep it short and to the point. 0.87. What is the ratio of the Balance of Payment (as % of service imports) in Tuvalu in 2008 to that in 2009?
Your answer should be compact. 1.04. What is the ratio of the Balance of Payment (as % of service imports) in Guatemala in 2008 to that in 2010?
Your response must be concise. 0.91. What is the ratio of the Balance of Payment (as % of service imports) of Tuvalu in 2008 to that in 2010?
Offer a very short reply. 1.1. What is the ratio of the Balance of Payment (as % of service imports) of Guatemala in 2008 to that in 2011?
Offer a terse response. 1.05. What is the ratio of the Balance of Payment (as % of service imports) of Nepal in 2008 to that in 2011?
Your answer should be compact. 1.09. What is the ratio of the Balance of Payment (as % of service imports) of Tuvalu in 2008 to that in 2011?
Offer a terse response. 1.1. What is the ratio of the Balance of Payment (as % of service imports) of Guatemala in 2008 to that in 2012?
Provide a short and direct response. 1.07. What is the ratio of the Balance of Payment (as % of service imports) of Nepal in 2008 to that in 2012?
Your response must be concise. 0.97. What is the ratio of the Balance of Payment (as % of service imports) in Tuvalu in 2008 to that in 2012?
Ensure brevity in your answer.  0.7. What is the ratio of the Balance of Payment (as % of service imports) in Guatemala in 2009 to that in 2010?
Offer a very short reply. 1.03. What is the ratio of the Balance of Payment (as % of service imports) of Nepal in 2009 to that in 2010?
Offer a very short reply. 1.12. What is the ratio of the Balance of Payment (as % of service imports) of Tuvalu in 2009 to that in 2010?
Provide a short and direct response. 1.06. What is the ratio of the Balance of Payment (as % of service imports) in Guatemala in 2009 to that in 2011?
Offer a terse response. 1.19. What is the ratio of the Balance of Payment (as % of service imports) in Nepal in 2009 to that in 2011?
Offer a very short reply. 1.26. What is the ratio of the Balance of Payment (as % of service imports) in Tuvalu in 2009 to that in 2011?
Provide a short and direct response. 1.06. What is the ratio of the Balance of Payment (as % of service imports) in Guatemala in 2009 to that in 2012?
Ensure brevity in your answer.  1.21. What is the ratio of the Balance of Payment (as % of service imports) of Nepal in 2009 to that in 2012?
Your answer should be compact. 1.12. What is the ratio of the Balance of Payment (as % of service imports) of Tuvalu in 2009 to that in 2012?
Ensure brevity in your answer.  0.67. What is the ratio of the Balance of Payment (as % of service imports) of Guatemala in 2010 to that in 2011?
Your answer should be very brief. 1.16. What is the ratio of the Balance of Payment (as % of service imports) of Nepal in 2010 to that in 2011?
Your answer should be very brief. 1.13. What is the ratio of the Balance of Payment (as % of service imports) in Tuvalu in 2010 to that in 2011?
Make the answer very short. 1. What is the ratio of the Balance of Payment (as % of service imports) in Guatemala in 2010 to that in 2012?
Make the answer very short. 1.17. What is the ratio of the Balance of Payment (as % of service imports) of Nepal in 2010 to that in 2012?
Give a very brief answer. 1. What is the ratio of the Balance of Payment (as % of service imports) of Tuvalu in 2010 to that in 2012?
Keep it short and to the point. 0.64. What is the ratio of the Balance of Payment (as % of service imports) in Nepal in 2011 to that in 2012?
Your response must be concise. 0.89. What is the ratio of the Balance of Payment (as % of service imports) in Tuvalu in 2011 to that in 2012?
Your answer should be very brief. 0.64. What is the difference between the highest and the second highest Balance of Payment (as % of service imports) in Guatemala?
Provide a succinct answer. 0.96. What is the difference between the highest and the second highest Balance of Payment (as % of service imports) of Nepal?
Your answer should be very brief. 5.32. What is the difference between the highest and the second highest Balance of Payment (as % of service imports) of Tuvalu?
Give a very brief answer. 0.4. What is the difference between the highest and the lowest Balance of Payment (as % of service imports) in Guatemala?
Offer a terse response. 5.72. What is the difference between the highest and the lowest Balance of Payment (as % of service imports) in Nepal?
Keep it short and to the point. 13.97. What is the difference between the highest and the lowest Balance of Payment (as % of service imports) in Tuvalu?
Offer a terse response. 20.57. 